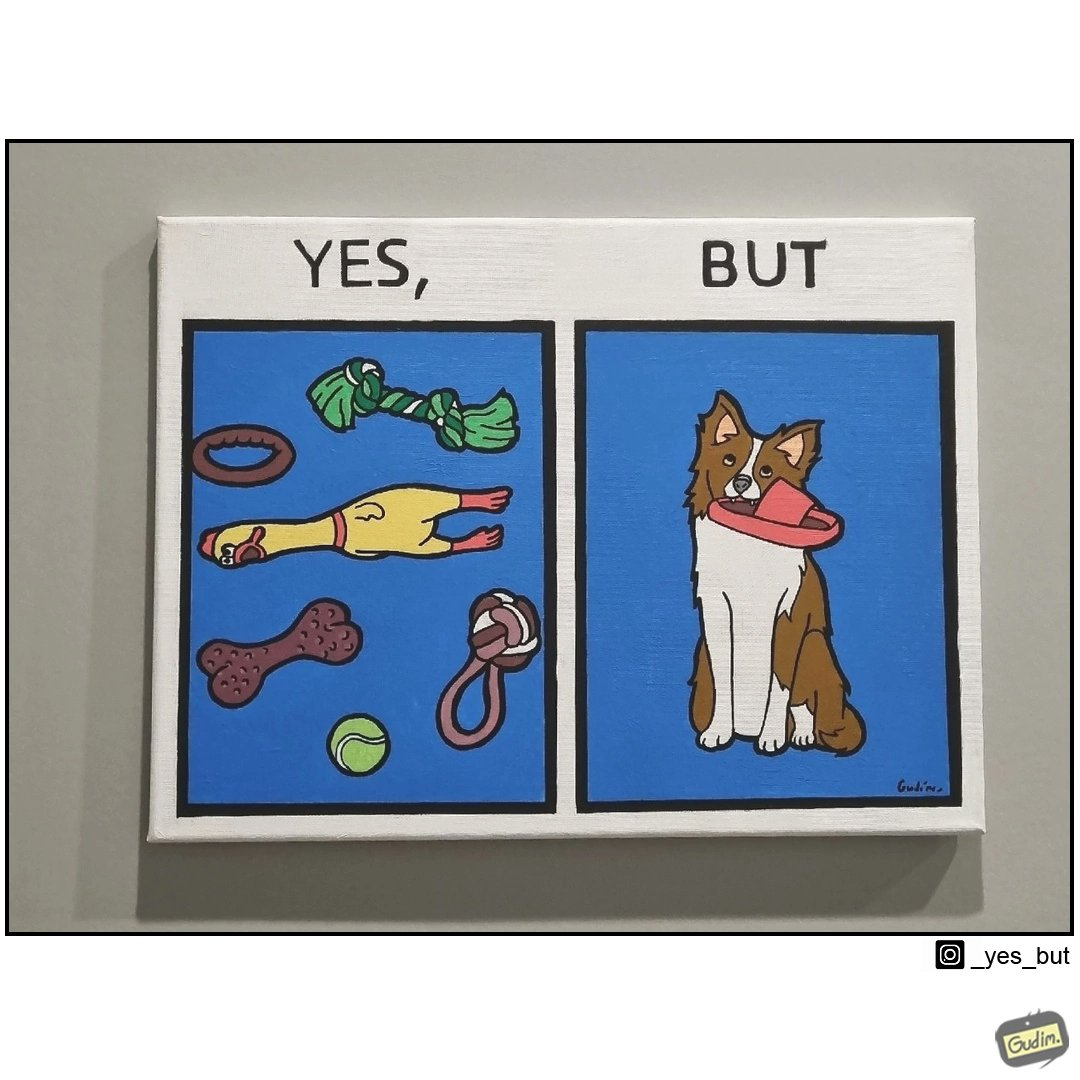What is shown in this image? the irony is that dog owners buy loads of toys for their dog but the dog's favourite toy is the owner's slippers 